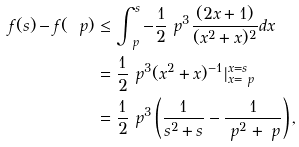Convert formula to latex. <formula><loc_0><loc_0><loc_500><loc_500>f ( s ) - f ( \ p ) & \leq \int _ { \ p } ^ { s } - \frac { 1 } { 2 } \ p ^ { 3 } \frac { ( 2 x + 1 ) } { ( x ^ { 2 } + x ) ^ { 2 } } d x \\ & = \frac { 1 } { 2 } \ p ^ { 3 } ( x ^ { 2 } + x ) ^ { - 1 } | _ { x = \ p } ^ { x = s } \\ & = \frac { 1 } { 2 } \ p ^ { 3 } \left ( \frac { 1 } { s ^ { 2 } + s } - \frac { 1 } { \ p ^ { 2 } + \ p } \right ) ,</formula> 